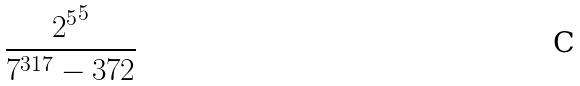<formula> <loc_0><loc_0><loc_500><loc_500>\frac { { 2 ^ { 5 } } ^ { 5 } } { 7 ^ { 3 1 7 } - 3 7 2 }</formula> 